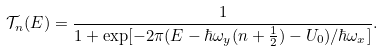<formula> <loc_0><loc_0><loc_500><loc_500>\mathcal { T } _ { n } ( E ) = \frac { 1 } { 1 + \exp [ - 2 \pi ( E - \hbar { \omega } _ { y } ( n + \frac { 1 } { 2 } ) - U _ { 0 } ) / \hbar { \omega } _ { x } ] } .</formula> 